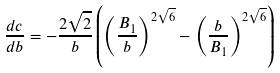Convert formula to latex. <formula><loc_0><loc_0><loc_500><loc_500>\frac { d c } { d b } = - \frac { 2 \sqrt { 2 } } { b } \left ( \left ( \frac { B _ { 1 } } { b } \right ) ^ { 2 \sqrt { 6 } } - \left ( \frac { b } { B _ { 1 } } \right ) ^ { 2 \sqrt { 6 } } \right )</formula> 